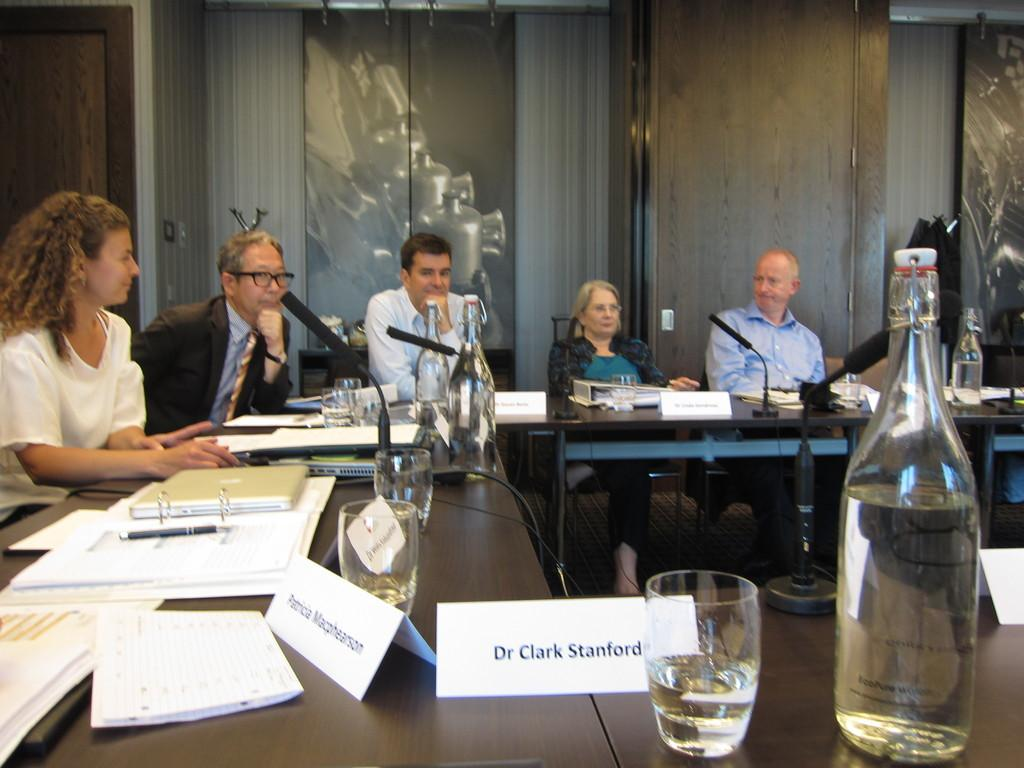<image>
Relay a brief, clear account of the picture shown. A place for Dr. Clark Stanford is designated at a large table with a paper name plate. 